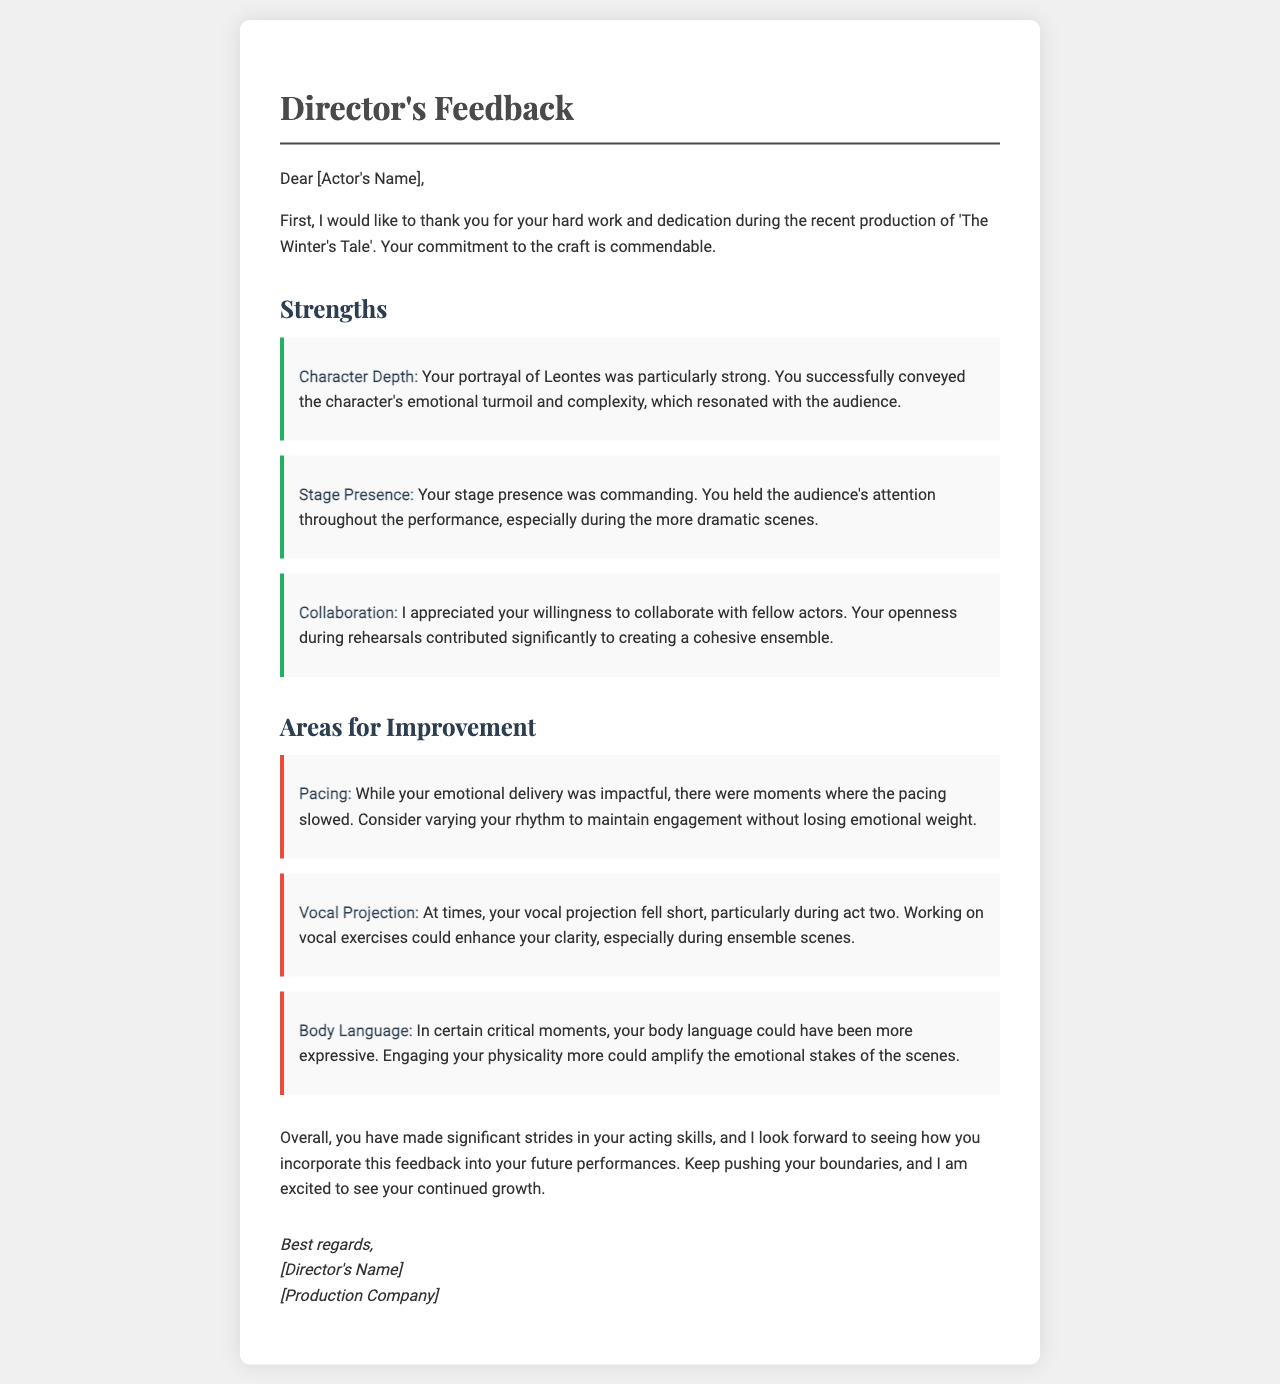What is the title of the production discussed? The title is mentioned as 'The Winter's Tale' in the opening section of the document.
Answer: The Winter's Tale Who wrote the feedback letter? The letter is signed off by [Director's Name], which is a placeholder for the actual name of the director.
Answer: [Director's Name] What aspect of the performance was praised related to the character? The feedback specifically mentions 'Character Depth' as a praised aspect of the actor's performance.
Answer: Character Depth What area for improvement relates to vocal skills? The feedback points out 'Vocal Projection' as an area for the actor to work on regarding vocal skills.
Answer: Vocal Projection How many strengths are highlighted in the letter? There are three strengths mentioned in the document.
Answer: 3 What is suggested to improve pacing? The document suggests varying rhythm to improve pacing.
Answer: Varying rhythm In which act did the vocal projection fall short? The letter indicates that the vocal projection issues were noticeable particularly during act two.
Answer: act two What did the director appreciate about the actor during rehearsals? The director appreciated the 'willingness to collaborate' with fellow actors during rehearsals.
Answer: willingness to collaborate What is the overall sentiment of the director regarding the actor's progress? The director expresses excitement about the actor's 'continued growth' and acknowledges significant strides in acting skills.
Answer: continued growth 